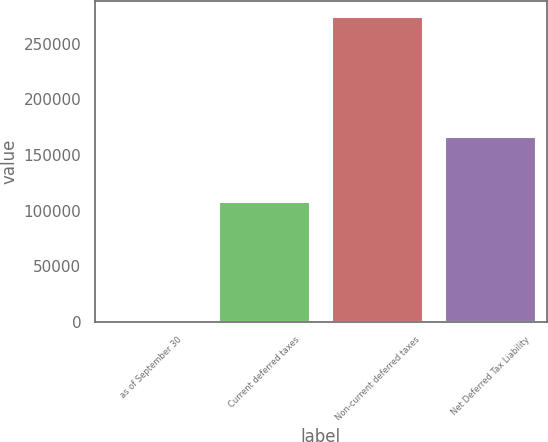Convert chart to OTSL. <chart><loc_0><loc_0><loc_500><loc_500><bar_chart><fcel>as of September 30<fcel>Current deferred taxes<fcel>Non-current deferred taxes<fcel>Net Deferred Tax Liability<nl><fcel>2011<fcel>107898<fcel>274435<fcel>166537<nl></chart> 